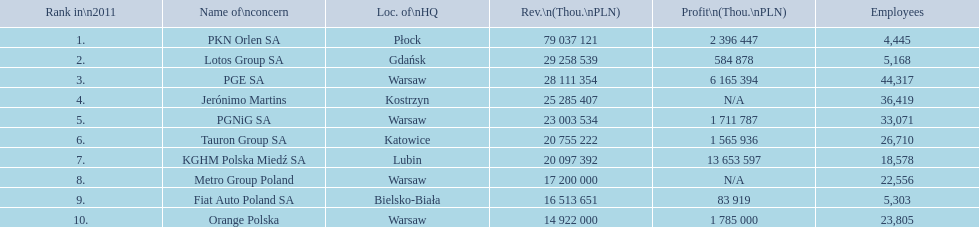Which company had the most revenue? PKN Orlen SA. 